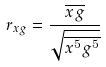<formula> <loc_0><loc_0><loc_500><loc_500>r _ { x g } = \frac { \overline { x g } } { \sqrt { \overline { x ^ { 5 } } \overline { g ^ { 5 } } } }</formula> 